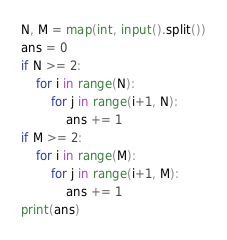<code> <loc_0><loc_0><loc_500><loc_500><_Python_>N, M = map(int, input().split())
ans = 0
if N >= 2:
    for i in range(N):
        for j in range(i+1, N):
            ans += 1
if M >= 2:
    for i in range(M):
        for j in range(i+1, M):
            ans += 1
print(ans)</code> 